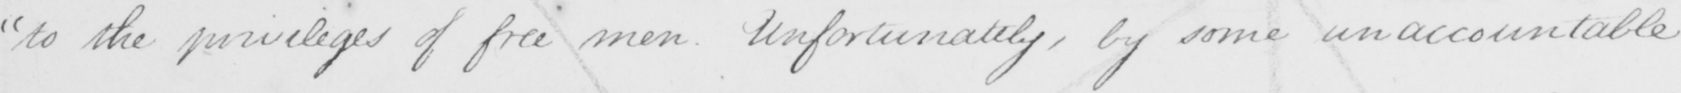Can you read and transcribe this handwriting? " to the privileges of free men . Unfortunately , by some unaccountable 